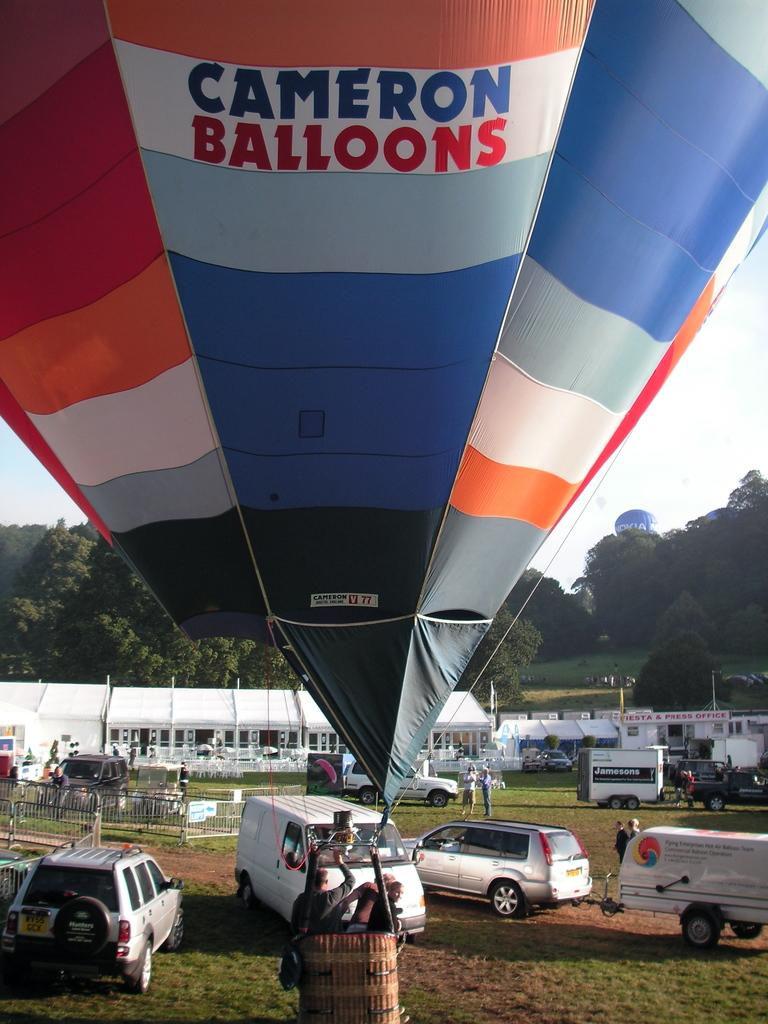What company does the balloon belong to?
Make the answer very short. Cameron balloons. What company name is written on the white trailer with the black banner?
Offer a very short reply. Unanswerable. 